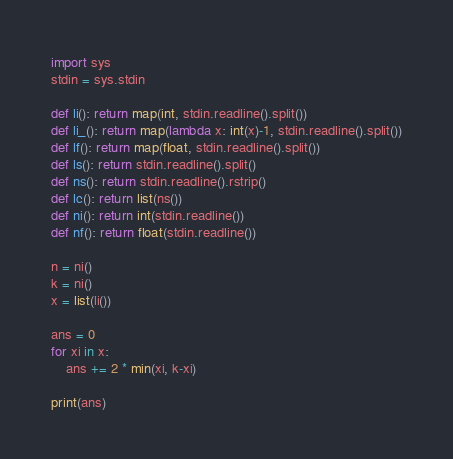Convert code to text. <code><loc_0><loc_0><loc_500><loc_500><_Python_>import sys
stdin = sys.stdin

def li(): return map(int, stdin.readline().split())
def li_(): return map(lambda x: int(x)-1, stdin.readline().split())
def lf(): return map(float, stdin.readline().split())
def ls(): return stdin.readline().split()
def ns(): return stdin.readline().rstrip()
def lc(): return list(ns())
def ni(): return int(stdin.readline())
def nf(): return float(stdin.readline())

n = ni()
k = ni()
x = list(li())

ans = 0
for xi in x:
    ans += 2 * min(xi, k-xi)
    
print(ans)</code> 